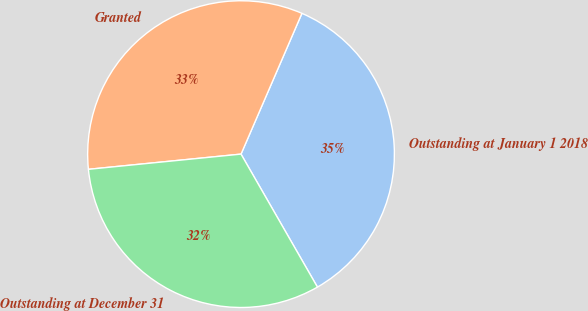<chart> <loc_0><loc_0><loc_500><loc_500><pie_chart><fcel>Outstanding at January 1 2018<fcel>Granted<fcel>Outstanding at December 31<nl><fcel>35.2%<fcel>33.08%<fcel>31.72%<nl></chart> 